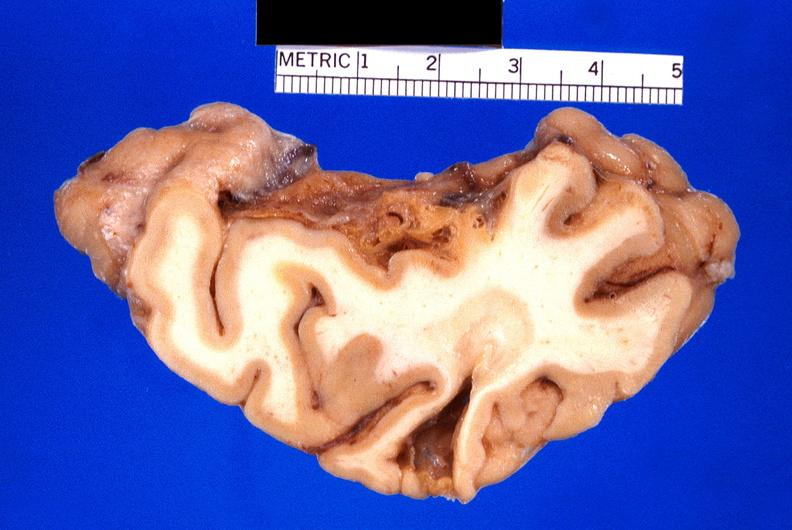does lesion show brain, old infarcts, embolic?
Answer the question using a single word or phrase. No 